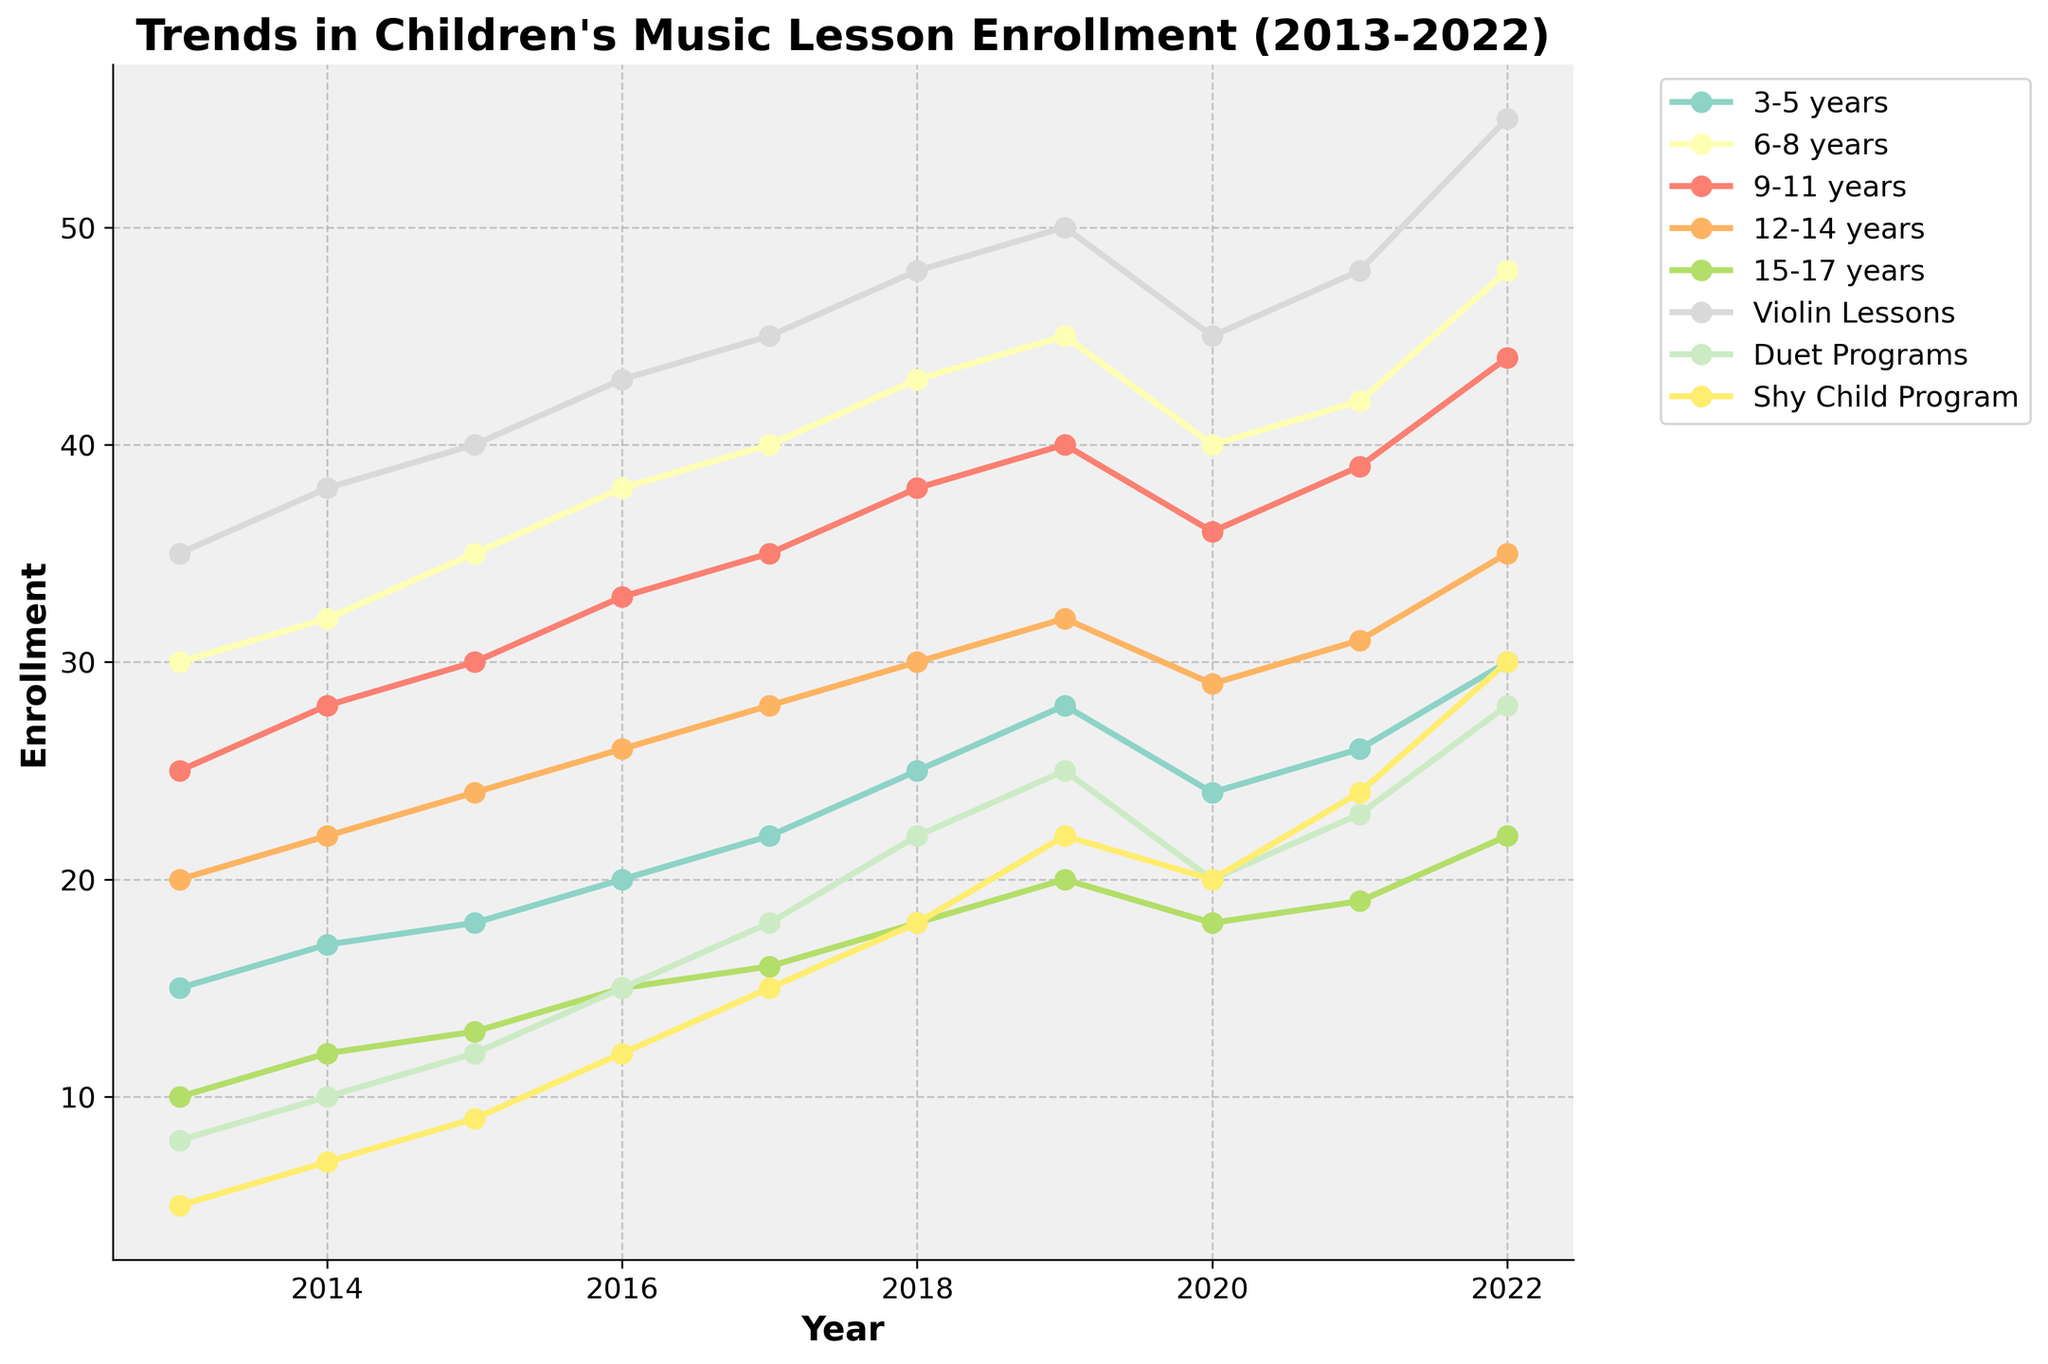What was the enrollment for 12-14 years in 2017? Locate the line for the 12-14 years age group and identify the value for 2017. The value is 28.
Answer: 28 How does the enrollment in the Shy Child Program in 2022 compare to 2020? Locate the Shy Child Program line. Enrollment in 2022 is 30 and in 2020 is 20. The difference is 30 - 20 = 10.
Answer: 10 Which age group had the highest enrollment in 2022? Look at the endpoints of all lines for 2022. The group 6-8 years has the highest enrollment at 48.
Answer: 6-8 years Is the trend for violin lessons consistently increasing over the decade? Follow the line for Violin Lessons from 2013 through 2022. The values are consistently increasing except for a dip in 2020.
Answer: No What was the combined enrollment for 3-5 years and 9-11 years in 2018? Find the values for both groups in 2018. Enrollment for 3-5 years is 25, and for 9-11 years, it's 38. Sum these values: 25 + 38 = 63.
Answer: 63 Which program saw the largest absolute increase in enrollment from 2013 to 2022? Calculate the differences between 2013 and 2022 for each program. Violin Lessons: 55 - 35 = 20, Duet Programs: 28 - 8 = 20, Shy Child Program: 30 - 5 = 25. The Shy Child Program had the largest increase of 25.
Answer: Shy Child Program Between 2016 and 2018, which group had the greatest rate of increase in enrollment? Calculate the rate of increase for each group: ((2018 value - 2016 value) / 2016 value) * 100. 
- 3-5 years: ((25 - 20) / 20) * 100 = 25%
- 6-8 years: ((43 - 38) / 38) * 100 = 13.16%
- 9-11 years: ((38 - 33) / 33) * 100 = 15.15%
- 12-14 years: ((30 - 26) / 26) * 100 = 15.38%
- 15-17 years: ((18 - 15) / 15) * 100 = 20%
3-5 years had the greatest rate of increase at 25%.
Answer: 3-5 years 